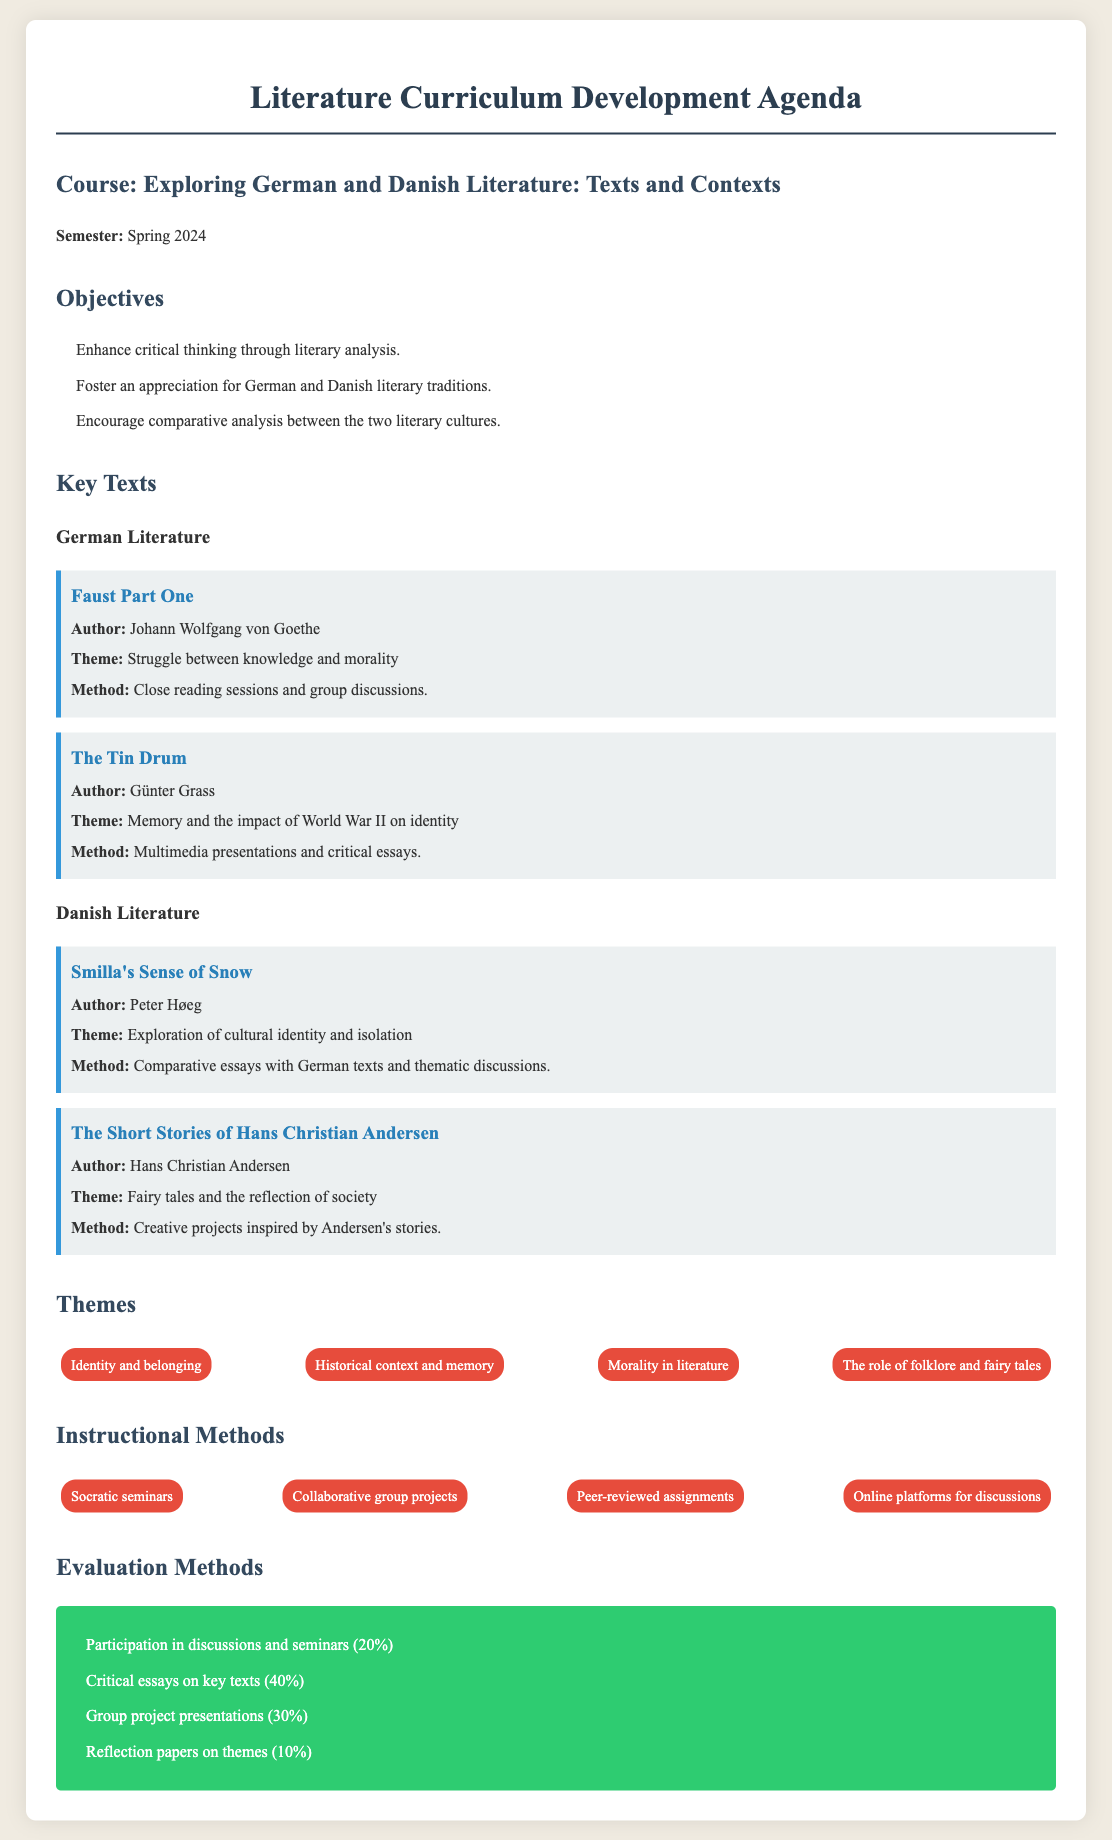What is the title of the course? The title of the course is mentioned in the document to specify the focus of the semester's literature curriculum.
Answer: Exploring German and Danish Literature: Texts and Contexts Who is the author of "Faust Part One"? The author is specified next to the title of the text in the German literature section.
Answer: Johann Wolfgang von Goethe What theme is associated with "The Tin Drum"? The theme is provided in the details of the text section and relates to the main ideas explored in the narrative.
Answer: Memory and the impact of World War II on identity How much percentage of the evaluation is for critical essays on key texts? The evaluation methods include percentages that specify how much weight each component carries towards the final grade.
Answer: 40% What instructional method involves group projects? The methods section outlines various instructional strategies used in the course.
Answer: Collaborative group projects Which theme focuses on societal reflections? The themes section lists various topics that will be explored in the course, with one specifically related to societal influences.
Answer: The role of folklore and fairy tales What is the expected participation percentage in discussions and seminars? This information is part of the evaluation methods provided in the document, indicating how much participation influences grades.
Answer: 20% How many key texts are listed under Danish literature? The document outlines the number of significant texts included in the curriculum, indicating the breadth of Danish literature covered.
Answer: 2 Which author is associated with "Smilla's Sense of Snow"? The author's name is provided alongside the title in the Danish literature section for clarity.
Answer: Peter Høeg 